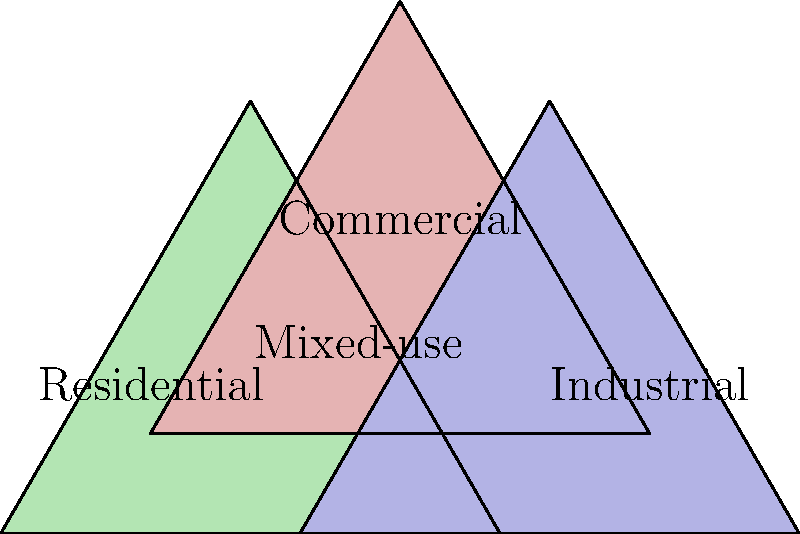In the urban planning diagram above, three zoning areas are represented by overlapping sets. What is the name typically given to the central area where all three zones intersect, and how might this concept align with your approach to city development as a centrist council member? 1. Identify the three main zones: The diagram shows three overlapping areas labeled Residential (green), Commercial (red), and Industrial (blue).

2. Locate the intersection: The central area where all three zones overlap is the key focus of this question.

3. Understand the concept: This overlapping area represents a mixed-use zone, where residential, commercial, and industrial activities can coexist.

4. Consider the implications: Mixed-use zoning allows for:
   a) More efficient land use
   b) Reduced transportation needs
   c) Increased walkability
   d) Greater economic diversity

5. Relate to centrist approach: As a centrist council member, this concept aligns well because:
   a) It balances the interests of different stakeholders (residents, businesses, industries)
   b) It promotes sustainable development by reducing urban sprawl
   c) It can lead to more vibrant, diverse communities
   d) It offers a compromise between strict zoning segregation and completely unregulated development

6. Policy implications: Supporting mixed-use zoning could be seen as a bipartisan approach, appealing to both pro-business and pro-community factions on the council.
Answer: Mixed-use zoning 